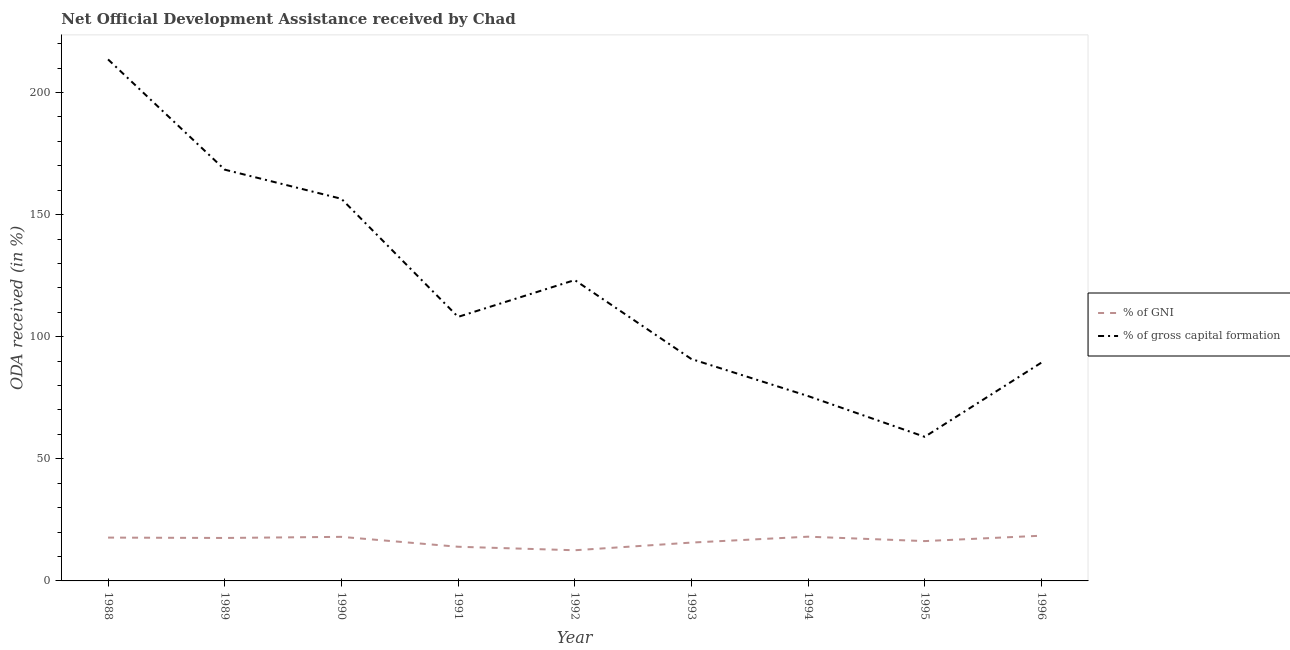Does the line corresponding to oda received as percentage of gross capital formation intersect with the line corresponding to oda received as percentage of gni?
Offer a terse response. No. What is the oda received as percentage of gross capital formation in 1994?
Your response must be concise. 75.71. Across all years, what is the maximum oda received as percentage of gross capital formation?
Offer a very short reply. 213.57. Across all years, what is the minimum oda received as percentage of gross capital formation?
Ensure brevity in your answer.  59.01. In which year was the oda received as percentage of gross capital formation maximum?
Make the answer very short. 1988. In which year was the oda received as percentage of gross capital formation minimum?
Give a very brief answer. 1995. What is the total oda received as percentage of gni in the graph?
Ensure brevity in your answer.  148.58. What is the difference between the oda received as percentage of gross capital formation in 1993 and that in 1995?
Keep it short and to the point. 31.86. What is the difference between the oda received as percentage of gni in 1988 and the oda received as percentage of gross capital formation in 1990?
Provide a short and direct response. -138.75. What is the average oda received as percentage of gni per year?
Keep it short and to the point. 16.51. In the year 1994, what is the difference between the oda received as percentage of gross capital formation and oda received as percentage of gni?
Give a very brief answer. 57.59. In how many years, is the oda received as percentage of gross capital formation greater than 120 %?
Give a very brief answer. 4. What is the ratio of the oda received as percentage of gni in 1991 to that in 1994?
Your answer should be compact. 0.77. Is the difference between the oda received as percentage of gni in 1991 and 1994 greater than the difference between the oda received as percentage of gross capital formation in 1991 and 1994?
Provide a succinct answer. No. What is the difference between the highest and the second highest oda received as percentage of gross capital formation?
Make the answer very short. 45.14. What is the difference between the highest and the lowest oda received as percentage of gni?
Ensure brevity in your answer.  5.96. In how many years, is the oda received as percentage of gni greater than the average oda received as percentage of gni taken over all years?
Your response must be concise. 5. How many lines are there?
Make the answer very short. 2. How many years are there in the graph?
Your answer should be compact. 9. What is the difference between two consecutive major ticks on the Y-axis?
Your answer should be very brief. 50. Does the graph contain grids?
Offer a very short reply. No. How many legend labels are there?
Keep it short and to the point. 2. What is the title of the graph?
Your answer should be very brief. Net Official Development Assistance received by Chad. Does "Registered firms" appear as one of the legend labels in the graph?
Give a very brief answer. No. What is the label or title of the Y-axis?
Offer a very short reply. ODA received (in %). What is the ODA received (in %) in % of GNI in 1988?
Keep it short and to the point. 17.74. What is the ODA received (in %) of % of gross capital formation in 1988?
Keep it short and to the point. 213.57. What is the ODA received (in %) in % of GNI in 1989?
Give a very brief answer. 17.59. What is the ODA received (in %) of % of gross capital formation in 1989?
Make the answer very short. 168.42. What is the ODA received (in %) in % of GNI in 1990?
Keep it short and to the point. 18.05. What is the ODA received (in %) of % of gross capital formation in 1990?
Make the answer very short. 156.49. What is the ODA received (in %) of % of GNI in 1991?
Offer a very short reply. 13.99. What is the ODA received (in %) in % of gross capital formation in 1991?
Provide a succinct answer. 108.13. What is the ODA received (in %) in % of GNI in 1992?
Make the answer very short. 12.56. What is the ODA received (in %) in % of gross capital formation in 1992?
Keep it short and to the point. 123.21. What is the ODA received (in %) in % of GNI in 1993?
Give a very brief answer. 15.7. What is the ODA received (in %) of % of gross capital formation in 1993?
Provide a short and direct response. 90.87. What is the ODA received (in %) in % of GNI in 1994?
Make the answer very short. 18.11. What is the ODA received (in %) of % of gross capital formation in 1994?
Your response must be concise. 75.71. What is the ODA received (in %) in % of GNI in 1995?
Make the answer very short. 16.31. What is the ODA received (in %) in % of gross capital formation in 1995?
Keep it short and to the point. 59.01. What is the ODA received (in %) of % of GNI in 1996?
Keep it short and to the point. 18.52. What is the ODA received (in %) in % of gross capital formation in 1996?
Provide a succinct answer. 89.4. Across all years, what is the maximum ODA received (in %) of % of GNI?
Offer a terse response. 18.52. Across all years, what is the maximum ODA received (in %) in % of gross capital formation?
Provide a short and direct response. 213.57. Across all years, what is the minimum ODA received (in %) of % of GNI?
Your answer should be compact. 12.56. Across all years, what is the minimum ODA received (in %) in % of gross capital formation?
Provide a succinct answer. 59.01. What is the total ODA received (in %) in % of GNI in the graph?
Your response must be concise. 148.58. What is the total ODA received (in %) in % of gross capital formation in the graph?
Ensure brevity in your answer.  1084.81. What is the difference between the ODA received (in %) in % of GNI in 1988 and that in 1989?
Your answer should be compact. 0.15. What is the difference between the ODA received (in %) of % of gross capital formation in 1988 and that in 1989?
Make the answer very short. 45.14. What is the difference between the ODA received (in %) of % of GNI in 1988 and that in 1990?
Give a very brief answer. -0.31. What is the difference between the ODA received (in %) in % of gross capital formation in 1988 and that in 1990?
Provide a short and direct response. 57.08. What is the difference between the ODA received (in %) of % of GNI in 1988 and that in 1991?
Ensure brevity in your answer.  3.75. What is the difference between the ODA received (in %) of % of gross capital formation in 1988 and that in 1991?
Ensure brevity in your answer.  105.44. What is the difference between the ODA received (in %) in % of GNI in 1988 and that in 1992?
Your answer should be very brief. 5.18. What is the difference between the ODA received (in %) of % of gross capital formation in 1988 and that in 1992?
Your answer should be very brief. 90.36. What is the difference between the ODA received (in %) of % of GNI in 1988 and that in 1993?
Provide a short and direct response. 2.04. What is the difference between the ODA received (in %) of % of gross capital formation in 1988 and that in 1993?
Offer a terse response. 122.7. What is the difference between the ODA received (in %) in % of GNI in 1988 and that in 1994?
Keep it short and to the point. -0.37. What is the difference between the ODA received (in %) in % of gross capital formation in 1988 and that in 1994?
Offer a terse response. 137.86. What is the difference between the ODA received (in %) of % of GNI in 1988 and that in 1995?
Your answer should be very brief. 1.43. What is the difference between the ODA received (in %) in % of gross capital formation in 1988 and that in 1995?
Offer a very short reply. 154.55. What is the difference between the ODA received (in %) of % of GNI in 1988 and that in 1996?
Your answer should be compact. -0.78. What is the difference between the ODA received (in %) in % of gross capital formation in 1988 and that in 1996?
Make the answer very short. 124.17. What is the difference between the ODA received (in %) of % of GNI in 1989 and that in 1990?
Offer a terse response. -0.46. What is the difference between the ODA received (in %) in % of gross capital formation in 1989 and that in 1990?
Your answer should be compact. 11.94. What is the difference between the ODA received (in %) of % of GNI in 1989 and that in 1991?
Your answer should be very brief. 3.6. What is the difference between the ODA received (in %) of % of gross capital formation in 1989 and that in 1991?
Ensure brevity in your answer.  60.29. What is the difference between the ODA received (in %) of % of GNI in 1989 and that in 1992?
Provide a short and direct response. 5.03. What is the difference between the ODA received (in %) of % of gross capital formation in 1989 and that in 1992?
Your answer should be very brief. 45.22. What is the difference between the ODA received (in %) of % of GNI in 1989 and that in 1993?
Your response must be concise. 1.89. What is the difference between the ODA received (in %) in % of gross capital formation in 1989 and that in 1993?
Ensure brevity in your answer.  77.55. What is the difference between the ODA received (in %) in % of GNI in 1989 and that in 1994?
Provide a short and direct response. -0.52. What is the difference between the ODA received (in %) in % of gross capital formation in 1989 and that in 1994?
Offer a very short reply. 92.72. What is the difference between the ODA received (in %) of % of GNI in 1989 and that in 1995?
Offer a very short reply. 1.28. What is the difference between the ODA received (in %) of % of gross capital formation in 1989 and that in 1995?
Ensure brevity in your answer.  109.41. What is the difference between the ODA received (in %) in % of GNI in 1989 and that in 1996?
Ensure brevity in your answer.  -0.93. What is the difference between the ODA received (in %) of % of gross capital formation in 1989 and that in 1996?
Your answer should be compact. 79.02. What is the difference between the ODA received (in %) of % of GNI in 1990 and that in 1991?
Your answer should be very brief. 4.06. What is the difference between the ODA received (in %) of % of gross capital formation in 1990 and that in 1991?
Ensure brevity in your answer.  48.36. What is the difference between the ODA received (in %) of % of GNI in 1990 and that in 1992?
Keep it short and to the point. 5.49. What is the difference between the ODA received (in %) in % of gross capital formation in 1990 and that in 1992?
Offer a terse response. 33.28. What is the difference between the ODA received (in %) of % of GNI in 1990 and that in 1993?
Provide a succinct answer. 2.35. What is the difference between the ODA received (in %) in % of gross capital formation in 1990 and that in 1993?
Provide a succinct answer. 65.62. What is the difference between the ODA received (in %) in % of GNI in 1990 and that in 1994?
Ensure brevity in your answer.  -0.07. What is the difference between the ODA received (in %) in % of gross capital formation in 1990 and that in 1994?
Ensure brevity in your answer.  80.78. What is the difference between the ODA received (in %) of % of GNI in 1990 and that in 1995?
Offer a very short reply. 1.74. What is the difference between the ODA received (in %) of % of gross capital formation in 1990 and that in 1995?
Make the answer very short. 97.47. What is the difference between the ODA received (in %) in % of GNI in 1990 and that in 1996?
Provide a succinct answer. -0.47. What is the difference between the ODA received (in %) of % of gross capital formation in 1990 and that in 1996?
Your answer should be very brief. 67.09. What is the difference between the ODA received (in %) of % of GNI in 1991 and that in 1992?
Your answer should be very brief. 1.43. What is the difference between the ODA received (in %) in % of gross capital formation in 1991 and that in 1992?
Provide a short and direct response. -15.07. What is the difference between the ODA received (in %) in % of GNI in 1991 and that in 1993?
Your response must be concise. -1.71. What is the difference between the ODA received (in %) of % of gross capital formation in 1991 and that in 1993?
Ensure brevity in your answer.  17.26. What is the difference between the ODA received (in %) of % of GNI in 1991 and that in 1994?
Ensure brevity in your answer.  -4.12. What is the difference between the ODA received (in %) of % of gross capital formation in 1991 and that in 1994?
Provide a short and direct response. 32.43. What is the difference between the ODA received (in %) in % of GNI in 1991 and that in 1995?
Make the answer very short. -2.32. What is the difference between the ODA received (in %) in % of gross capital formation in 1991 and that in 1995?
Your answer should be compact. 49.12. What is the difference between the ODA received (in %) in % of GNI in 1991 and that in 1996?
Your answer should be very brief. -4.53. What is the difference between the ODA received (in %) of % of gross capital formation in 1991 and that in 1996?
Offer a terse response. 18.73. What is the difference between the ODA received (in %) of % of GNI in 1992 and that in 1993?
Make the answer very short. -3.14. What is the difference between the ODA received (in %) in % of gross capital formation in 1992 and that in 1993?
Offer a very short reply. 32.33. What is the difference between the ODA received (in %) in % of GNI in 1992 and that in 1994?
Give a very brief answer. -5.55. What is the difference between the ODA received (in %) of % of gross capital formation in 1992 and that in 1994?
Ensure brevity in your answer.  47.5. What is the difference between the ODA received (in %) of % of GNI in 1992 and that in 1995?
Your response must be concise. -3.75. What is the difference between the ODA received (in %) of % of gross capital formation in 1992 and that in 1995?
Keep it short and to the point. 64.19. What is the difference between the ODA received (in %) of % of GNI in 1992 and that in 1996?
Offer a very short reply. -5.96. What is the difference between the ODA received (in %) of % of gross capital formation in 1992 and that in 1996?
Give a very brief answer. 33.81. What is the difference between the ODA received (in %) of % of GNI in 1993 and that in 1994?
Make the answer very short. -2.41. What is the difference between the ODA received (in %) of % of gross capital formation in 1993 and that in 1994?
Give a very brief answer. 15.17. What is the difference between the ODA received (in %) of % of GNI in 1993 and that in 1995?
Your response must be concise. -0.61. What is the difference between the ODA received (in %) in % of gross capital formation in 1993 and that in 1995?
Offer a terse response. 31.86. What is the difference between the ODA received (in %) in % of GNI in 1993 and that in 1996?
Keep it short and to the point. -2.82. What is the difference between the ODA received (in %) of % of gross capital formation in 1993 and that in 1996?
Provide a succinct answer. 1.47. What is the difference between the ODA received (in %) of % of GNI in 1994 and that in 1995?
Ensure brevity in your answer.  1.8. What is the difference between the ODA received (in %) in % of gross capital formation in 1994 and that in 1995?
Offer a very short reply. 16.69. What is the difference between the ODA received (in %) in % of GNI in 1994 and that in 1996?
Your answer should be very brief. -0.41. What is the difference between the ODA received (in %) in % of gross capital formation in 1994 and that in 1996?
Ensure brevity in your answer.  -13.7. What is the difference between the ODA received (in %) in % of GNI in 1995 and that in 1996?
Provide a short and direct response. -2.21. What is the difference between the ODA received (in %) in % of gross capital formation in 1995 and that in 1996?
Ensure brevity in your answer.  -30.39. What is the difference between the ODA received (in %) in % of GNI in 1988 and the ODA received (in %) in % of gross capital formation in 1989?
Ensure brevity in your answer.  -150.68. What is the difference between the ODA received (in %) in % of GNI in 1988 and the ODA received (in %) in % of gross capital formation in 1990?
Offer a terse response. -138.75. What is the difference between the ODA received (in %) of % of GNI in 1988 and the ODA received (in %) of % of gross capital formation in 1991?
Ensure brevity in your answer.  -90.39. What is the difference between the ODA received (in %) in % of GNI in 1988 and the ODA received (in %) in % of gross capital formation in 1992?
Give a very brief answer. -105.46. What is the difference between the ODA received (in %) in % of GNI in 1988 and the ODA received (in %) in % of gross capital formation in 1993?
Provide a short and direct response. -73.13. What is the difference between the ODA received (in %) in % of GNI in 1988 and the ODA received (in %) in % of gross capital formation in 1994?
Ensure brevity in your answer.  -57.96. What is the difference between the ODA received (in %) in % of GNI in 1988 and the ODA received (in %) in % of gross capital formation in 1995?
Provide a short and direct response. -41.27. What is the difference between the ODA received (in %) of % of GNI in 1988 and the ODA received (in %) of % of gross capital formation in 1996?
Provide a succinct answer. -71.66. What is the difference between the ODA received (in %) of % of GNI in 1989 and the ODA received (in %) of % of gross capital formation in 1990?
Offer a very short reply. -138.9. What is the difference between the ODA received (in %) in % of GNI in 1989 and the ODA received (in %) in % of gross capital formation in 1991?
Offer a terse response. -90.54. What is the difference between the ODA received (in %) in % of GNI in 1989 and the ODA received (in %) in % of gross capital formation in 1992?
Your answer should be very brief. -105.61. What is the difference between the ODA received (in %) of % of GNI in 1989 and the ODA received (in %) of % of gross capital formation in 1993?
Make the answer very short. -73.28. What is the difference between the ODA received (in %) in % of GNI in 1989 and the ODA received (in %) in % of gross capital formation in 1994?
Keep it short and to the point. -58.11. What is the difference between the ODA received (in %) in % of GNI in 1989 and the ODA received (in %) in % of gross capital formation in 1995?
Provide a short and direct response. -41.42. What is the difference between the ODA received (in %) of % of GNI in 1989 and the ODA received (in %) of % of gross capital formation in 1996?
Ensure brevity in your answer.  -71.81. What is the difference between the ODA received (in %) in % of GNI in 1990 and the ODA received (in %) in % of gross capital formation in 1991?
Ensure brevity in your answer.  -90.08. What is the difference between the ODA received (in %) in % of GNI in 1990 and the ODA received (in %) in % of gross capital formation in 1992?
Keep it short and to the point. -105.16. What is the difference between the ODA received (in %) of % of GNI in 1990 and the ODA received (in %) of % of gross capital formation in 1993?
Ensure brevity in your answer.  -72.82. What is the difference between the ODA received (in %) of % of GNI in 1990 and the ODA received (in %) of % of gross capital formation in 1994?
Make the answer very short. -57.66. What is the difference between the ODA received (in %) in % of GNI in 1990 and the ODA received (in %) in % of gross capital formation in 1995?
Keep it short and to the point. -40.97. What is the difference between the ODA received (in %) of % of GNI in 1990 and the ODA received (in %) of % of gross capital formation in 1996?
Your answer should be very brief. -71.35. What is the difference between the ODA received (in %) in % of GNI in 1991 and the ODA received (in %) in % of gross capital formation in 1992?
Your answer should be compact. -109.21. What is the difference between the ODA received (in %) in % of GNI in 1991 and the ODA received (in %) in % of gross capital formation in 1993?
Keep it short and to the point. -76.88. What is the difference between the ODA received (in %) of % of GNI in 1991 and the ODA received (in %) of % of gross capital formation in 1994?
Ensure brevity in your answer.  -61.71. What is the difference between the ODA received (in %) in % of GNI in 1991 and the ODA received (in %) in % of gross capital formation in 1995?
Give a very brief answer. -45.02. What is the difference between the ODA received (in %) of % of GNI in 1991 and the ODA received (in %) of % of gross capital formation in 1996?
Offer a terse response. -75.41. What is the difference between the ODA received (in %) of % of GNI in 1992 and the ODA received (in %) of % of gross capital formation in 1993?
Give a very brief answer. -78.31. What is the difference between the ODA received (in %) in % of GNI in 1992 and the ODA received (in %) in % of gross capital formation in 1994?
Offer a terse response. -63.15. What is the difference between the ODA received (in %) of % of GNI in 1992 and the ODA received (in %) of % of gross capital formation in 1995?
Provide a short and direct response. -46.46. What is the difference between the ODA received (in %) of % of GNI in 1992 and the ODA received (in %) of % of gross capital formation in 1996?
Provide a succinct answer. -76.84. What is the difference between the ODA received (in %) of % of GNI in 1993 and the ODA received (in %) of % of gross capital formation in 1994?
Make the answer very short. -60. What is the difference between the ODA received (in %) of % of GNI in 1993 and the ODA received (in %) of % of gross capital formation in 1995?
Offer a very short reply. -43.31. What is the difference between the ODA received (in %) in % of GNI in 1993 and the ODA received (in %) in % of gross capital formation in 1996?
Offer a terse response. -73.7. What is the difference between the ODA received (in %) of % of GNI in 1994 and the ODA received (in %) of % of gross capital formation in 1995?
Your response must be concise. -40.9. What is the difference between the ODA received (in %) of % of GNI in 1994 and the ODA received (in %) of % of gross capital formation in 1996?
Offer a very short reply. -71.29. What is the difference between the ODA received (in %) of % of GNI in 1995 and the ODA received (in %) of % of gross capital formation in 1996?
Offer a very short reply. -73.09. What is the average ODA received (in %) in % of GNI per year?
Provide a short and direct response. 16.51. What is the average ODA received (in %) of % of gross capital formation per year?
Offer a terse response. 120.53. In the year 1988, what is the difference between the ODA received (in %) in % of GNI and ODA received (in %) in % of gross capital formation?
Ensure brevity in your answer.  -195.83. In the year 1989, what is the difference between the ODA received (in %) of % of GNI and ODA received (in %) of % of gross capital formation?
Your answer should be very brief. -150.83. In the year 1990, what is the difference between the ODA received (in %) of % of GNI and ODA received (in %) of % of gross capital formation?
Give a very brief answer. -138.44. In the year 1991, what is the difference between the ODA received (in %) in % of GNI and ODA received (in %) in % of gross capital formation?
Your response must be concise. -94.14. In the year 1992, what is the difference between the ODA received (in %) in % of GNI and ODA received (in %) in % of gross capital formation?
Provide a short and direct response. -110.65. In the year 1993, what is the difference between the ODA received (in %) in % of GNI and ODA received (in %) in % of gross capital formation?
Give a very brief answer. -75.17. In the year 1994, what is the difference between the ODA received (in %) in % of GNI and ODA received (in %) in % of gross capital formation?
Your answer should be very brief. -57.59. In the year 1995, what is the difference between the ODA received (in %) in % of GNI and ODA received (in %) in % of gross capital formation?
Offer a very short reply. -42.7. In the year 1996, what is the difference between the ODA received (in %) of % of GNI and ODA received (in %) of % of gross capital formation?
Your answer should be very brief. -70.88. What is the ratio of the ODA received (in %) in % of GNI in 1988 to that in 1989?
Your response must be concise. 1.01. What is the ratio of the ODA received (in %) in % of gross capital formation in 1988 to that in 1989?
Ensure brevity in your answer.  1.27. What is the ratio of the ODA received (in %) of % of GNI in 1988 to that in 1990?
Ensure brevity in your answer.  0.98. What is the ratio of the ODA received (in %) of % of gross capital formation in 1988 to that in 1990?
Your response must be concise. 1.36. What is the ratio of the ODA received (in %) of % of GNI in 1988 to that in 1991?
Provide a short and direct response. 1.27. What is the ratio of the ODA received (in %) of % of gross capital formation in 1988 to that in 1991?
Ensure brevity in your answer.  1.98. What is the ratio of the ODA received (in %) of % of GNI in 1988 to that in 1992?
Your answer should be compact. 1.41. What is the ratio of the ODA received (in %) in % of gross capital formation in 1988 to that in 1992?
Provide a short and direct response. 1.73. What is the ratio of the ODA received (in %) of % of GNI in 1988 to that in 1993?
Ensure brevity in your answer.  1.13. What is the ratio of the ODA received (in %) of % of gross capital formation in 1988 to that in 1993?
Offer a very short reply. 2.35. What is the ratio of the ODA received (in %) of % of GNI in 1988 to that in 1994?
Provide a short and direct response. 0.98. What is the ratio of the ODA received (in %) of % of gross capital formation in 1988 to that in 1994?
Your answer should be very brief. 2.82. What is the ratio of the ODA received (in %) of % of GNI in 1988 to that in 1995?
Your response must be concise. 1.09. What is the ratio of the ODA received (in %) of % of gross capital formation in 1988 to that in 1995?
Your answer should be very brief. 3.62. What is the ratio of the ODA received (in %) in % of GNI in 1988 to that in 1996?
Keep it short and to the point. 0.96. What is the ratio of the ODA received (in %) in % of gross capital formation in 1988 to that in 1996?
Give a very brief answer. 2.39. What is the ratio of the ODA received (in %) of % of GNI in 1989 to that in 1990?
Offer a terse response. 0.97. What is the ratio of the ODA received (in %) in % of gross capital formation in 1989 to that in 1990?
Provide a succinct answer. 1.08. What is the ratio of the ODA received (in %) in % of GNI in 1989 to that in 1991?
Provide a short and direct response. 1.26. What is the ratio of the ODA received (in %) of % of gross capital formation in 1989 to that in 1991?
Keep it short and to the point. 1.56. What is the ratio of the ODA received (in %) in % of GNI in 1989 to that in 1992?
Give a very brief answer. 1.4. What is the ratio of the ODA received (in %) of % of gross capital formation in 1989 to that in 1992?
Ensure brevity in your answer.  1.37. What is the ratio of the ODA received (in %) in % of GNI in 1989 to that in 1993?
Keep it short and to the point. 1.12. What is the ratio of the ODA received (in %) of % of gross capital formation in 1989 to that in 1993?
Your answer should be very brief. 1.85. What is the ratio of the ODA received (in %) of % of GNI in 1989 to that in 1994?
Your response must be concise. 0.97. What is the ratio of the ODA received (in %) in % of gross capital formation in 1989 to that in 1994?
Keep it short and to the point. 2.22. What is the ratio of the ODA received (in %) of % of GNI in 1989 to that in 1995?
Keep it short and to the point. 1.08. What is the ratio of the ODA received (in %) of % of gross capital formation in 1989 to that in 1995?
Provide a short and direct response. 2.85. What is the ratio of the ODA received (in %) of % of GNI in 1989 to that in 1996?
Your response must be concise. 0.95. What is the ratio of the ODA received (in %) in % of gross capital formation in 1989 to that in 1996?
Offer a very short reply. 1.88. What is the ratio of the ODA received (in %) in % of GNI in 1990 to that in 1991?
Offer a terse response. 1.29. What is the ratio of the ODA received (in %) of % of gross capital formation in 1990 to that in 1991?
Your answer should be compact. 1.45. What is the ratio of the ODA received (in %) in % of GNI in 1990 to that in 1992?
Keep it short and to the point. 1.44. What is the ratio of the ODA received (in %) of % of gross capital formation in 1990 to that in 1992?
Offer a very short reply. 1.27. What is the ratio of the ODA received (in %) of % of GNI in 1990 to that in 1993?
Keep it short and to the point. 1.15. What is the ratio of the ODA received (in %) in % of gross capital formation in 1990 to that in 1993?
Make the answer very short. 1.72. What is the ratio of the ODA received (in %) in % of GNI in 1990 to that in 1994?
Your answer should be very brief. 1. What is the ratio of the ODA received (in %) in % of gross capital formation in 1990 to that in 1994?
Offer a very short reply. 2.07. What is the ratio of the ODA received (in %) in % of GNI in 1990 to that in 1995?
Offer a very short reply. 1.11. What is the ratio of the ODA received (in %) of % of gross capital formation in 1990 to that in 1995?
Provide a succinct answer. 2.65. What is the ratio of the ODA received (in %) of % of GNI in 1990 to that in 1996?
Provide a succinct answer. 0.97. What is the ratio of the ODA received (in %) in % of gross capital formation in 1990 to that in 1996?
Give a very brief answer. 1.75. What is the ratio of the ODA received (in %) of % of GNI in 1991 to that in 1992?
Ensure brevity in your answer.  1.11. What is the ratio of the ODA received (in %) in % of gross capital formation in 1991 to that in 1992?
Provide a short and direct response. 0.88. What is the ratio of the ODA received (in %) of % of GNI in 1991 to that in 1993?
Offer a terse response. 0.89. What is the ratio of the ODA received (in %) in % of gross capital formation in 1991 to that in 1993?
Give a very brief answer. 1.19. What is the ratio of the ODA received (in %) in % of GNI in 1991 to that in 1994?
Your answer should be very brief. 0.77. What is the ratio of the ODA received (in %) in % of gross capital formation in 1991 to that in 1994?
Your answer should be compact. 1.43. What is the ratio of the ODA received (in %) of % of GNI in 1991 to that in 1995?
Your answer should be compact. 0.86. What is the ratio of the ODA received (in %) of % of gross capital formation in 1991 to that in 1995?
Offer a terse response. 1.83. What is the ratio of the ODA received (in %) of % of GNI in 1991 to that in 1996?
Ensure brevity in your answer.  0.76. What is the ratio of the ODA received (in %) in % of gross capital formation in 1991 to that in 1996?
Your response must be concise. 1.21. What is the ratio of the ODA received (in %) in % of GNI in 1992 to that in 1993?
Offer a very short reply. 0.8. What is the ratio of the ODA received (in %) in % of gross capital formation in 1992 to that in 1993?
Provide a succinct answer. 1.36. What is the ratio of the ODA received (in %) in % of GNI in 1992 to that in 1994?
Provide a succinct answer. 0.69. What is the ratio of the ODA received (in %) in % of gross capital formation in 1992 to that in 1994?
Your response must be concise. 1.63. What is the ratio of the ODA received (in %) of % of GNI in 1992 to that in 1995?
Give a very brief answer. 0.77. What is the ratio of the ODA received (in %) of % of gross capital formation in 1992 to that in 1995?
Provide a short and direct response. 2.09. What is the ratio of the ODA received (in %) in % of GNI in 1992 to that in 1996?
Provide a short and direct response. 0.68. What is the ratio of the ODA received (in %) in % of gross capital formation in 1992 to that in 1996?
Provide a succinct answer. 1.38. What is the ratio of the ODA received (in %) of % of GNI in 1993 to that in 1994?
Make the answer very short. 0.87. What is the ratio of the ODA received (in %) in % of gross capital formation in 1993 to that in 1994?
Provide a succinct answer. 1.2. What is the ratio of the ODA received (in %) in % of GNI in 1993 to that in 1995?
Make the answer very short. 0.96. What is the ratio of the ODA received (in %) of % of gross capital formation in 1993 to that in 1995?
Your response must be concise. 1.54. What is the ratio of the ODA received (in %) of % of GNI in 1993 to that in 1996?
Your answer should be very brief. 0.85. What is the ratio of the ODA received (in %) of % of gross capital formation in 1993 to that in 1996?
Provide a succinct answer. 1.02. What is the ratio of the ODA received (in %) of % of GNI in 1994 to that in 1995?
Your response must be concise. 1.11. What is the ratio of the ODA received (in %) in % of gross capital formation in 1994 to that in 1995?
Offer a terse response. 1.28. What is the ratio of the ODA received (in %) in % of GNI in 1994 to that in 1996?
Keep it short and to the point. 0.98. What is the ratio of the ODA received (in %) in % of gross capital formation in 1994 to that in 1996?
Provide a short and direct response. 0.85. What is the ratio of the ODA received (in %) of % of GNI in 1995 to that in 1996?
Your answer should be very brief. 0.88. What is the ratio of the ODA received (in %) of % of gross capital formation in 1995 to that in 1996?
Offer a very short reply. 0.66. What is the difference between the highest and the second highest ODA received (in %) in % of GNI?
Your answer should be very brief. 0.41. What is the difference between the highest and the second highest ODA received (in %) of % of gross capital formation?
Provide a succinct answer. 45.14. What is the difference between the highest and the lowest ODA received (in %) in % of GNI?
Your answer should be very brief. 5.96. What is the difference between the highest and the lowest ODA received (in %) in % of gross capital formation?
Ensure brevity in your answer.  154.55. 